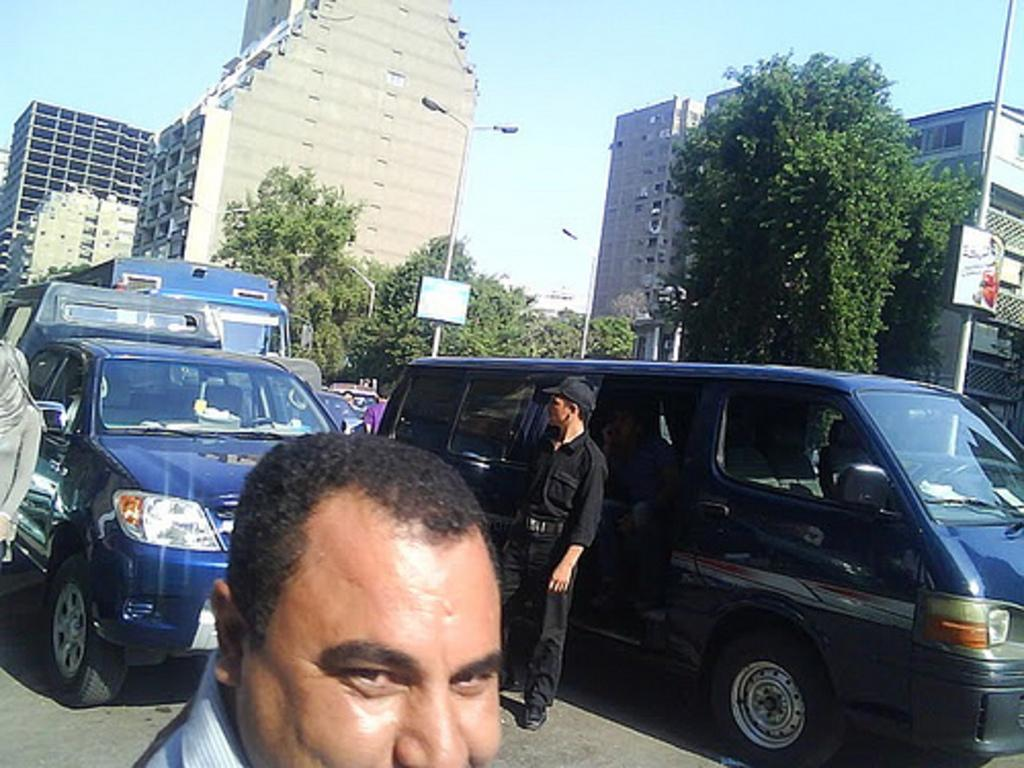What can be seen on the road in the image? There are vehicles and people on the road in the image. What is located behind the vehicles? There are trees behind the vehicles. What can be seen in the background of the image? Street lights, buildings, a board, and the sky are visible in the background. Can you tell me how many people are in jail in the image? There is no jail or people in jail present in the image. What type of whistle can be heard in the background of the image? There is no whistle present in the image, and therefore no sound can be heard. 